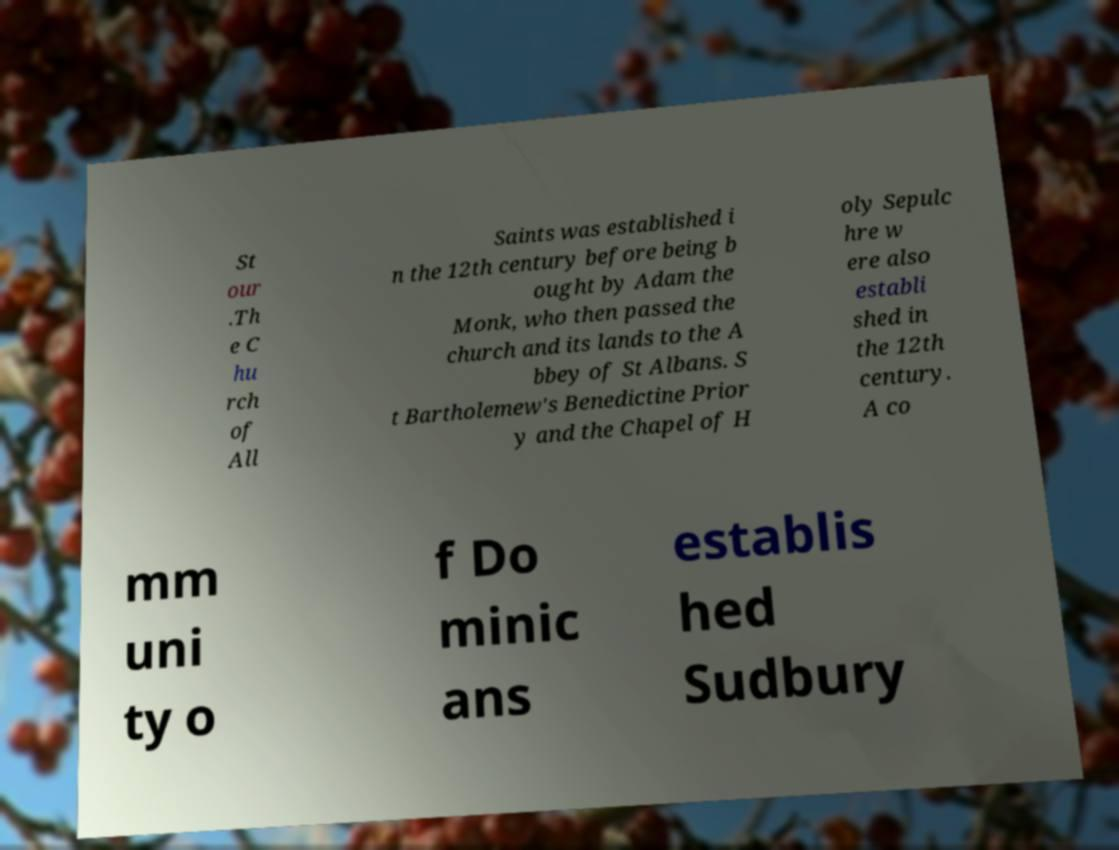Could you assist in decoding the text presented in this image and type it out clearly? St our .Th e C hu rch of All Saints was established i n the 12th century before being b ought by Adam the Monk, who then passed the church and its lands to the A bbey of St Albans. S t Bartholemew's Benedictine Prior y and the Chapel of H oly Sepulc hre w ere also establi shed in the 12th century. A co mm uni ty o f Do minic ans establis hed Sudbury 